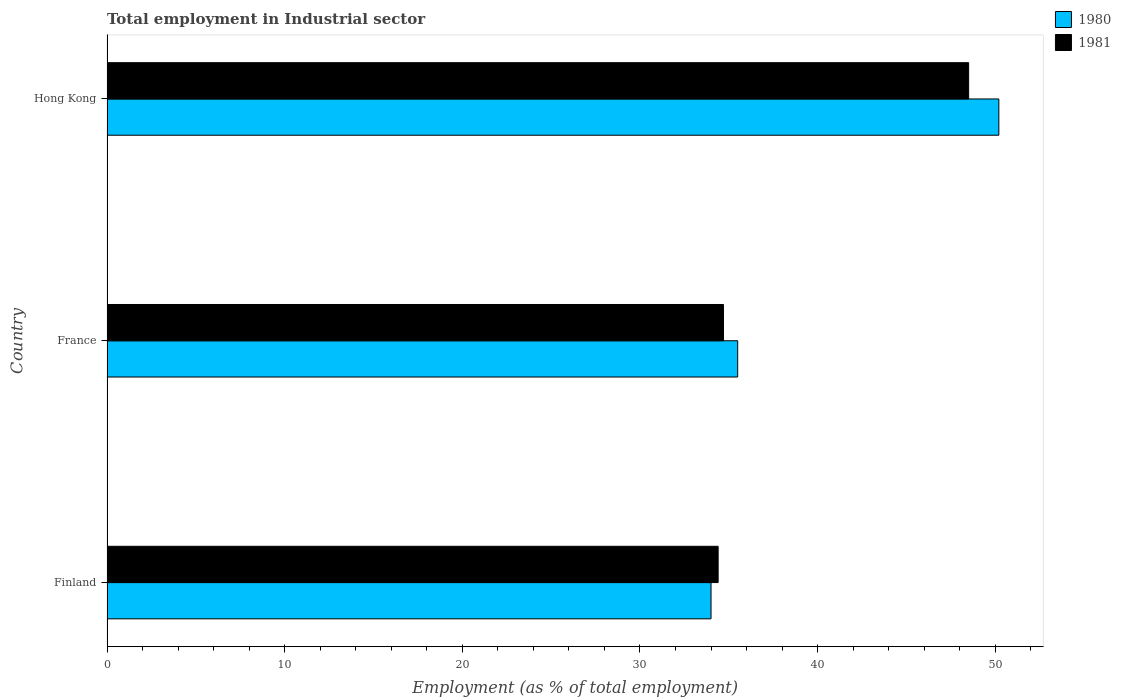How many different coloured bars are there?
Your answer should be very brief. 2. Are the number of bars on each tick of the Y-axis equal?
Offer a terse response. Yes. How many bars are there on the 3rd tick from the top?
Ensure brevity in your answer.  2. What is the employment in industrial sector in 1980 in France?
Make the answer very short. 35.5. Across all countries, what is the maximum employment in industrial sector in 1980?
Your answer should be very brief. 50.2. In which country was the employment in industrial sector in 1980 maximum?
Keep it short and to the point. Hong Kong. In which country was the employment in industrial sector in 1981 minimum?
Ensure brevity in your answer.  Finland. What is the total employment in industrial sector in 1981 in the graph?
Your answer should be compact. 117.6. What is the difference between the employment in industrial sector in 1980 in Finland and that in Hong Kong?
Offer a very short reply. -16.2. What is the difference between the employment in industrial sector in 1980 in Finland and the employment in industrial sector in 1981 in France?
Your answer should be very brief. -0.7. What is the average employment in industrial sector in 1980 per country?
Give a very brief answer. 39.9. What is the difference between the employment in industrial sector in 1980 and employment in industrial sector in 1981 in Finland?
Your response must be concise. -0.4. In how many countries, is the employment in industrial sector in 1980 greater than 46 %?
Give a very brief answer. 1. What is the ratio of the employment in industrial sector in 1980 in Finland to that in Hong Kong?
Provide a succinct answer. 0.68. Is the difference between the employment in industrial sector in 1980 in Finland and France greater than the difference between the employment in industrial sector in 1981 in Finland and France?
Your answer should be compact. No. What is the difference between the highest and the second highest employment in industrial sector in 1980?
Provide a succinct answer. 14.7. What is the difference between the highest and the lowest employment in industrial sector in 1981?
Keep it short and to the point. 14.1. In how many countries, is the employment in industrial sector in 1980 greater than the average employment in industrial sector in 1980 taken over all countries?
Provide a short and direct response. 1. Is the sum of the employment in industrial sector in 1981 in Finland and Hong Kong greater than the maximum employment in industrial sector in 1980 across all countries?
Ensure brevity in your answer.  Yes. What does the 1st bar from the bottom in Hong Kong represents?
Your response must be concise. 1980. How many countries are there in the graph?
Ensure brevity in your answer.  3. What is the difference between two consecutive major ticks on the X-axis?
Keep it short and to the point. 10. Where does the legend appear in the graph?
Offer a very short reply. Top right. What is the title of the graph?
Provide a succinct answer. Total employment in Industrial sector. What is the label or title of the X-axis?
Make the answer very short. Employment (as % of total employment). What is the Employment (as % of total employment) of 1980 in Finland?
Give a very brief answer. 34. What is the Employment (as % of total employment) in 1981 in Finland?
Provide a short and direct response. 34.4. What is the Employment (as % of total employment) of 1980 in France?
Ensure brevity in your answer.  35.5. What is the Employment (as % of total employment) in 1981 in France?
Provide a short and direct response. 34.7. What is the Employment (as % of total employment) of 1980 in Hong Kong?
Provide a succinct answer. 50.2. What is the Employment (as % of total employment) in 1981 in Hong Kong?
Provide a succinct answer. 48.5. Across all countries, what is the maximum Employment (as % of total employment) in 1980?
Make the answer very short. 50.2. Across all countries, what is the maximum Employment (as % of total employment) in 1981?
Make the answer very short. 48.5. Across all countries, what is the minimum Employment (as % of total employment) of 1981?
Keep it short and to the point. 34.4. What is the total Employment (as % of total employment) of 1980 in the graph?
Your answer should be very brief. 119.7. What is the total Employment (as % of total employment) of 1981 in the graph?
Offer a terse response. 117.6. What is the difference between the Employment (as % of total employment) of 1980 in Finland and that in Hong Kong?
Your answer should be very brief. -16.2. What is the difference between the Employment (as % of total employment) in 1981 in Finland and that in Hong Kong?
Offer a very short reply. -14.1. What is the difference between the Employment (as % of total employment) in 1980 in France and that in Hong Kong?
Ensure brevity in your answer.  -14.7. What is the average Employment (as % of total employment) of 1980 per country?
Keep it short and to the point. 39.9. What is the average Employment (as % of total employment) of 1981 per country?
Offer a very short reply. 39.2. What is the difference between the Employment (as % of total employment) of 1980 and Employment (as % of total employment) of 1981 in Finland?
Offer a very short reply. -0.4. What is the difference between the Employment (as % of total employment) in 1980 and Employment (as % of total employment) in 1981 in France?
Provide a short and direct response. 0.8. What is the difference between the Employment (as % of total employment) of 1980 and Employment (as % of total employment) of 1981 in Hong Kong?
Provide a short and direct response. 1.7. What is the ratio of the Employment (as % of total employment) of 1980 in Finland to that in France?
Your response must be concise. 0.96. What is the ratio of the Employment (as % of total employment) in 1981 in Finland to that in France?
Your response must be concise. 0.99. What is the ratio of the Employment (as % of total employment) of 1980 in Finland to that in Hong Kong?
Keep it short and to the point. 0.68. What is the ratio of the Employment (as % of total employment) of 1981 in Finland to that in Hong Kong?
Your response must be concise. 0.71. What is the ratio of the Employment (as % of total employment) in 1980 in France to that in Hong Kong?
Provide a short and direct response. 0.71. What is the ratio of the Employment (as % of total employment) of 1981 in France to that in Hong Kong?
Give a very brief answer. 0.72. What is the difference between the highest and the second highest Employment (as % of total employment) in 1980?
Offer a terse response. 14.7. What is the difference between the highest and the second highest Employment (as % of total employment) in 1981?
Keep it short and to the point. 13.8. What is the difference between the highest and the lowest Employment (as % of total employment) of 1980?
Your answer should be very brief. 16.2. What is the difference between the highest and the lowest Employment (as % of total employment) of 1981?
Keep it short and to the point. 14.1. 